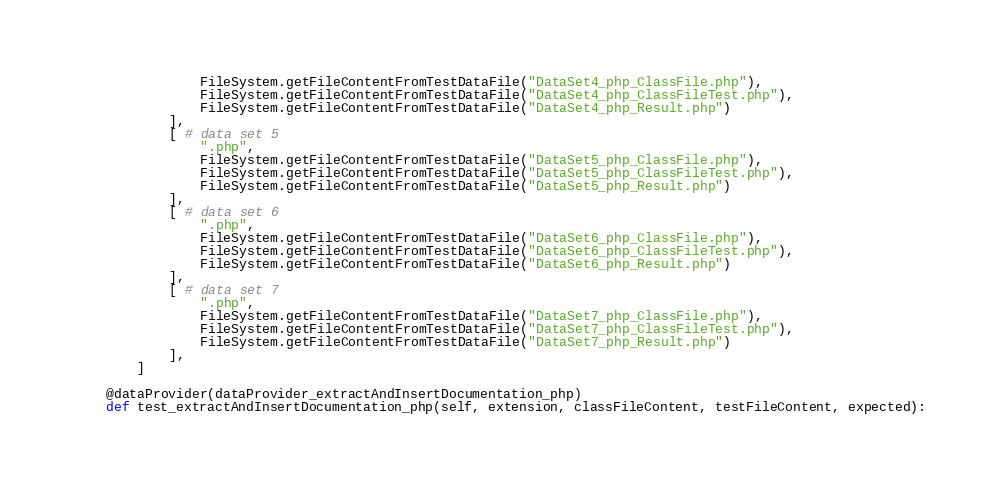Convert code to text. <code><loc_0><loc_0><loc_500><loc_500><_Python_>                FileSystem.getFileContentFromTestDataFile("DataSet4_php_ClassFile.php"),
                FileSystem.getFileContentFromTestDataFile("DataSet4_php_ClassFileTest.php"),
                FileSystem.getFileContentFromTestDataFile("DataSet4_php_Result.php")
            ],
            [ # data set 5
                ".php", 
                FileSystem.getFileContentFromTestDataFile("DataSet5_php_ClassFile.php"),
                FileSystem.getFileContentFromTestDataFile("DataSet5_php_ClassFileTest.php"),
                FileSystem.getFileContentFromTestDataFile("DataSet5_php_Result.php")
            ],
            [ # data set 6
                ".php", 
                FileSystem.getFileContentFromTestDataFile("DataSet6_php_ClassFile.php"),
                FileSystem.getFileContentFromTestDataFile("DataSet6_php_ClassFileTest.php"),
                FileSystem.getFileContentFromTestDataFile("DataSet6_php_Result.php")
            ],
            [ # data set 7
                ".php", 
                FileSystem.getFileContentFromTestDataFile("DataSet7_php_ClassFile.php"),
                FileSystem.getFileContentFromTestDataFile("DataSet7_php_ClassFileTest.php"),
                FileSystem.getFileContentFromTestDataFile("DataSet7_php_Result.php")
            ],
        ]

    @dataProvider(dataProvider_extractAndInsertDocumentation_php)
    def test_extractAndInsertDocumentation_php(self, extension, classFileContent, testFileContent, expected):</code> 